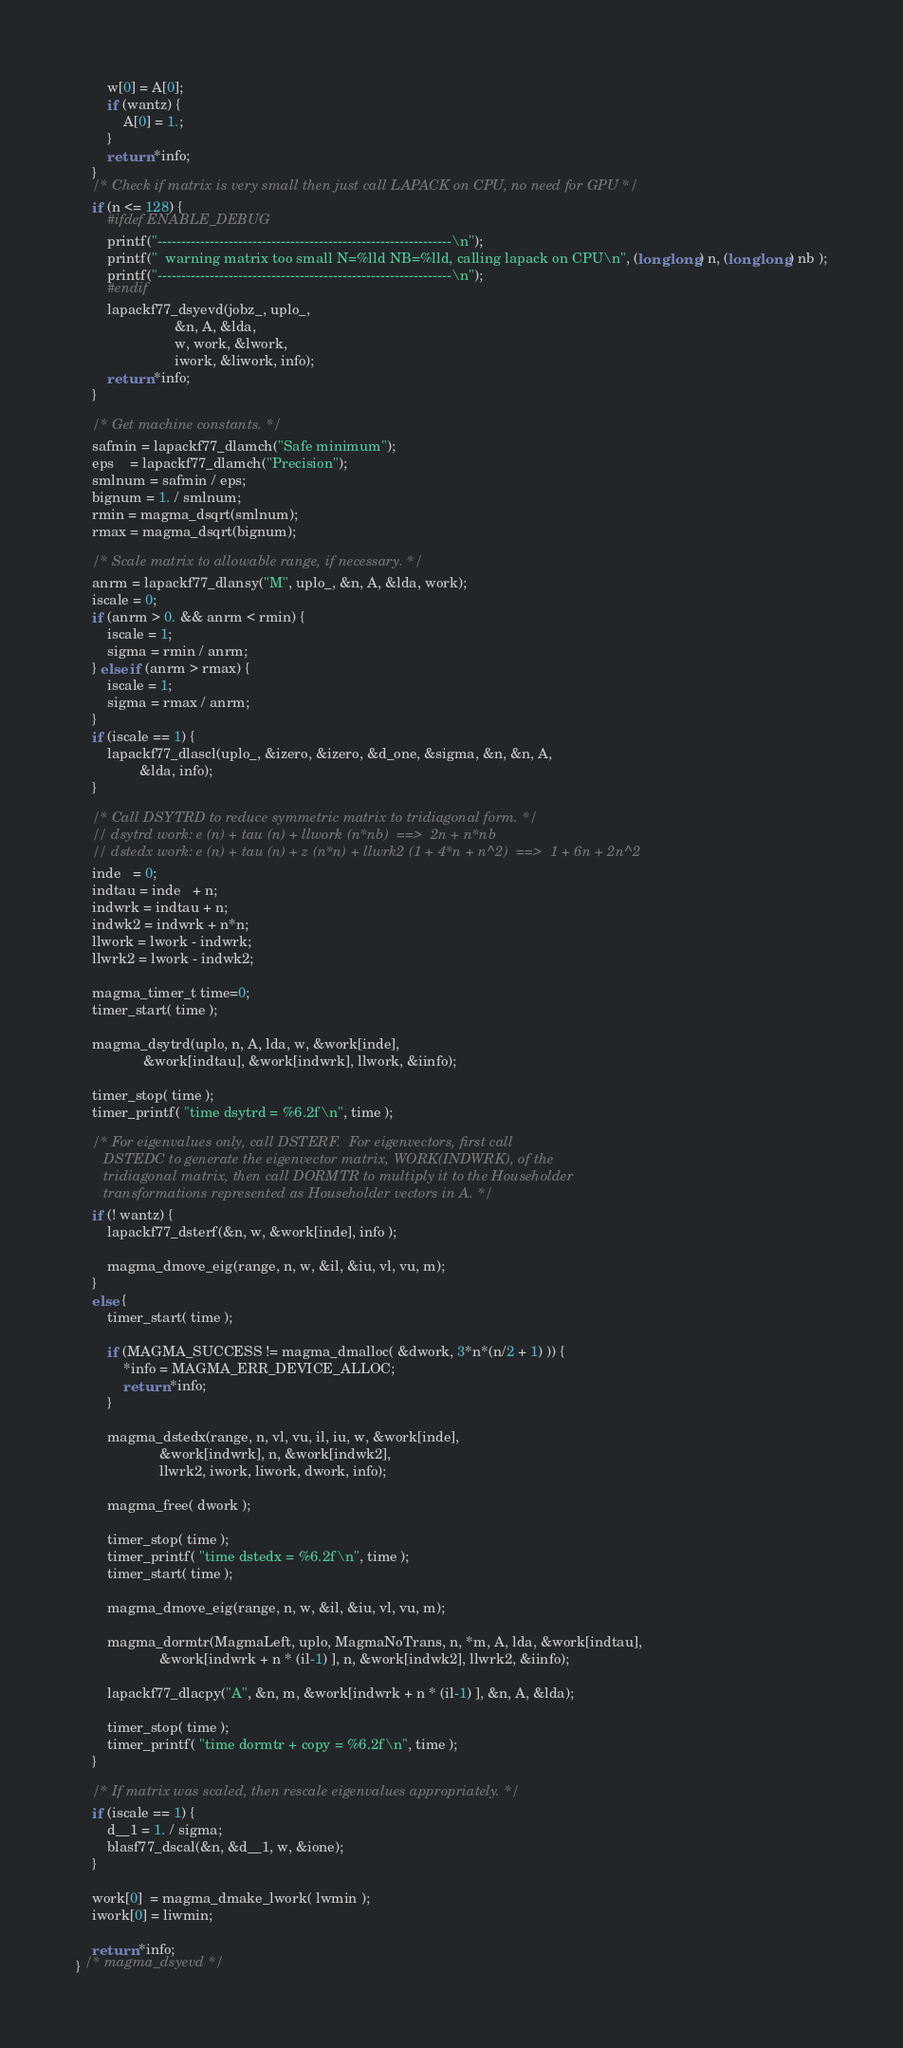Convert code to text. <code><loc_0><loc_0><loc_500><loc_500><_C++_>        w[0] = A[0];
        if (wantz) {
            A[0] = 1.;
        }
        return *info;
    }
    /* Check if matrix is very small then just call LAPACK on CPU, no need for GPU */
    if (n <= 128) {
        #ifdef ENABLE_DEBUG
        printf("--------------------------------------------------------------\n");
        printf("  warning matrix too small N=%lld NB=%lld, calling lapack on CPU\n", (long long) n, (long long) nb );
        printf("--------------------------------------------------------------\n");
        #endif
        lapackf77_dsyevd(jobz_, uplo_,
                         &n, A, &lda,
                         w, work, &lwork,
                         iwork, &liwork, info);
        return *info;
    }

    /* Get machine constants. */
    safmin = lapackf77_dlamch("Safe minimum");
    eps    = lapackf77_dlamch("Precision");
    smlnum = safmin / eps;
    bignum = 1. / smlnum;
    rmin = magma_dsqrt(smlnum);
    rmax = magma_dsqrt(bignum);

    /* Scale matrix to allowable range, if necessary. */
    anrm = lapackf77_dlansy("M", uplo_, &n, A, &lda, work);
    iscale = 0;
    if (anrm > 0. && anrm < rmin) {
        iscale = 1;
        sigma = rmin / anrm;
    } else if (anrm > rmax) {
        iscale = 1;
        sigma = rmax / anrm;
    }
    if (iscale == 1) {
        lapackf77_dlascl(uplo_, &izero, &izero, &d_one, &sigma, &n, &n, A,
                &lda, info);
    }

    /* Call DSYTRD to reduce symmetric matrix to tridiagonal form. */
    // dsytrd work: e (n) + tau (n) + llwork (n*nb)  ==>  2n + n*nb
    // dstedx work: e (n) + tau (n) + z (n*n) + llwrk2 (1 + 4*n + n^2)  ==>  1 + 6n + 2n^2
    inde   = 0;
    indtau = inde   + n;
    indwrk = indtau + n;
    indwk2 = indwrk + n*n;
    llwork = lwork - indwrk;
    llwrk2 = lwork - indwk2;

    magma_timer_t time=0;
    timer_start( time );

    magma_dsytrd(uplo, n, A, lda, w, &work[inde],
                 &work[indtau], &work[indwrk], llwork, &iinfo);

    timer_stop( time );
    timer_printf( "time dsytrd = %6.2f\n", time );

    /* For eigenvalues only, call DSTERF.  For eigenvectors, first call
       DSTEDC to generate the eigenvector matrix, WORK(INDWRK), of the
       tridiagonal matrix, then call DORMTR to multiply it to the Householder
       transformations represented as Householder vectors in A. */
    if (! wantz) {
        lapackf77_dsterf(&n, w, &work[inde], info );

        magma_dmove_eig(range, n, w, &il, &iu, vl, vu, m);
    }
    else {
        timer_start( time );

        if (MAGMA_SUCCESS != magma_dmalloc( &dwork, 3*n*(n/2 + 1) )) {
            *info = MAGMA_ERR_DEVICE_ALLOC;
            return *info;
        }

        magma_dstedx(range, n, vl, vu, il, iu, w, &work[inde],
                     &work[indwrk], n, &work[indwk2],
                     llwrk2, iwork, liwork, dwork, info);

        magma_free( dwork );

        timer_stop( time );
        timer_printf( "time dstedx = %6.2f\n", time );
        timer_start( time );

        magma_dmove_eig(range, n, w, &il, &iu, vl, vu, m);

        magma_dormtr(MagmaLeft, uplo, MagmaNoTrans, n, *m, A, lda, &work[indtau],
                     &work[indwrk + n * (il-1) ], n, &work[indwk2], llwrk2, &iinfo);

        lapackf77_dlacpy("A", &n, m, &work[indwrk + n * (il-1) ], &n, A, &lda);

        timer_stop( time );
        timer_printf( "time dormtr + copy = %6.2f\n", time );
    }

    /* If matrix was scaled, then rescale eigenvalues appropriately. */
    if (iscale == 1) {
        d__1 = 1. / sigma;
        blasf77_dscal(&n, &d__1, w, &ione);
    }

    work[0]  = magma_dmake_lwork( lwmin );
    iwork[0] = liwmin;

    return *info;
} /* magma_dsyevd */
</code> 